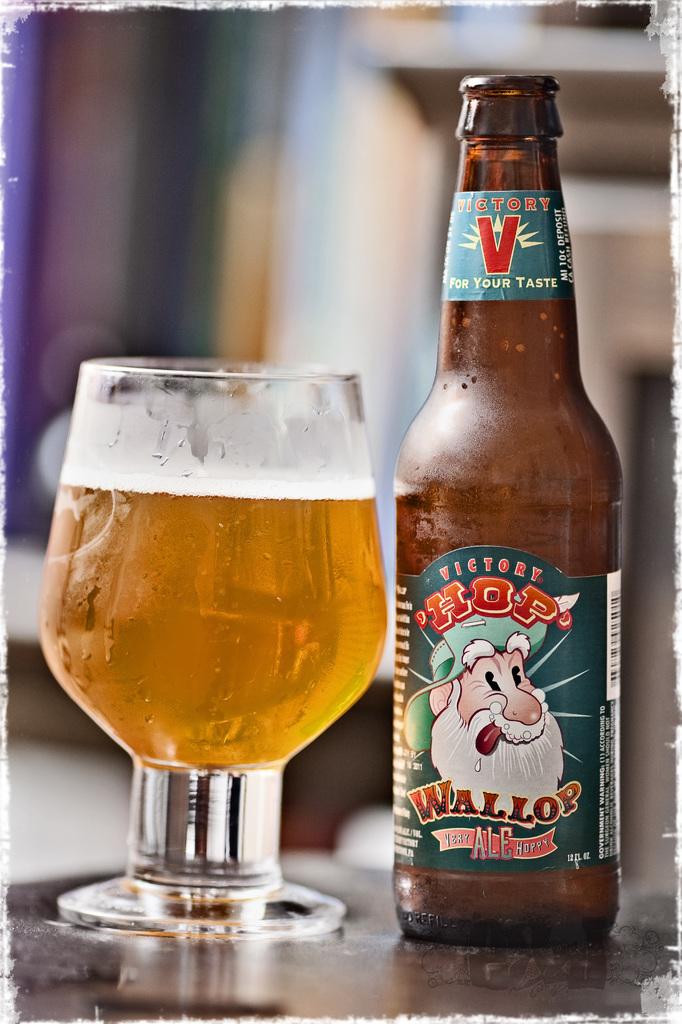What is the first word on the label?
Provide a succinct answer. Victory. What brand of beer is this?
Provide a short and direct response. Hop wallop. 